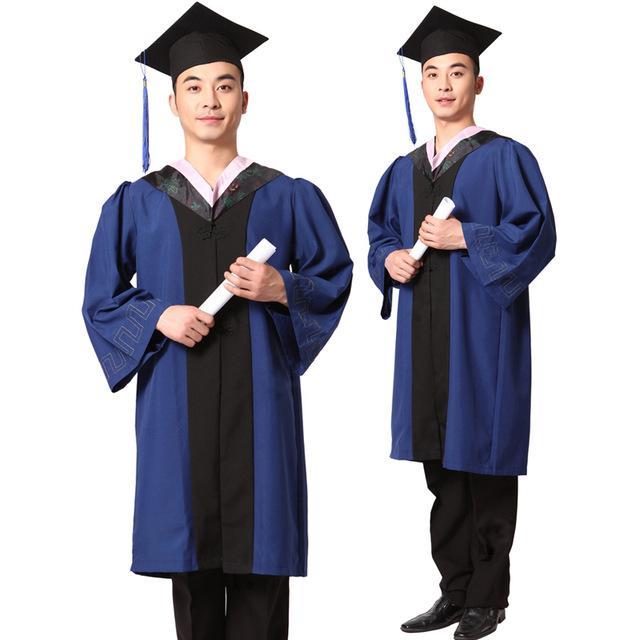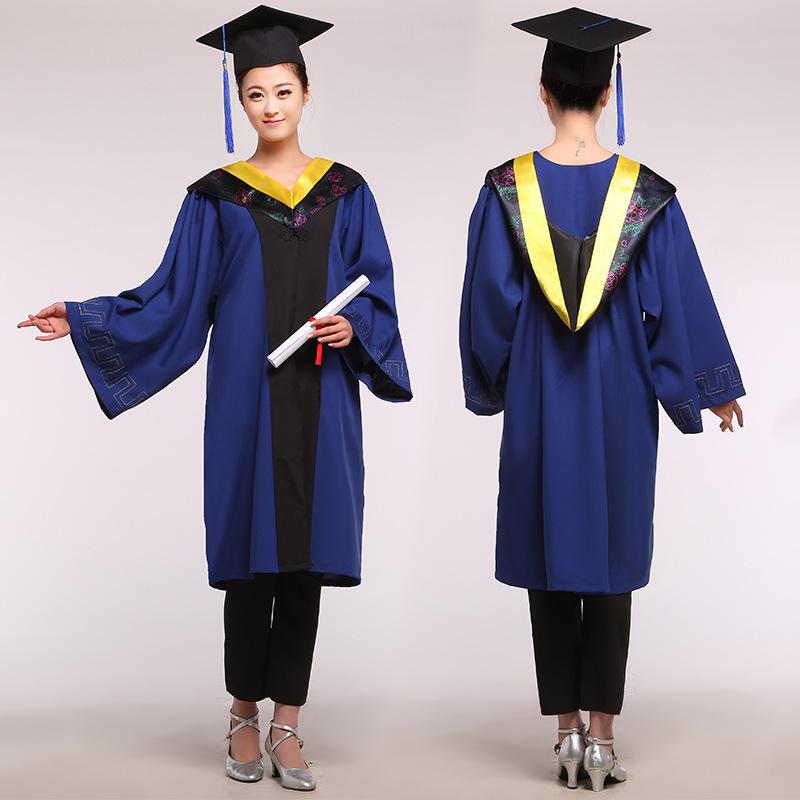The first image is the image on the left, the second image is the image on the right. Analyze the images presented: Is the assertion "There is a woman in the image on the right." valid? Answer yes or no. Yes. 